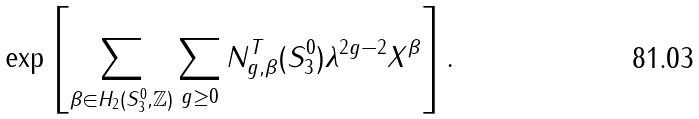<formula> <loc_0><loc_0><loc_500><loc_500>\exp \left [ \sum _ { \beta \in H _ { 2 } ( S _ { 3 } ^ { 0 } , \mathbb { Z } ) } \sum _ { g \geq 0 } N _ { g , \beta } ^ { T } ( S _ { 3 } ^ { 0 } ) \lambda ^ { 2 g - 2 } X ^ { \beta } \right ] .</formula> 